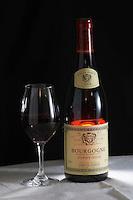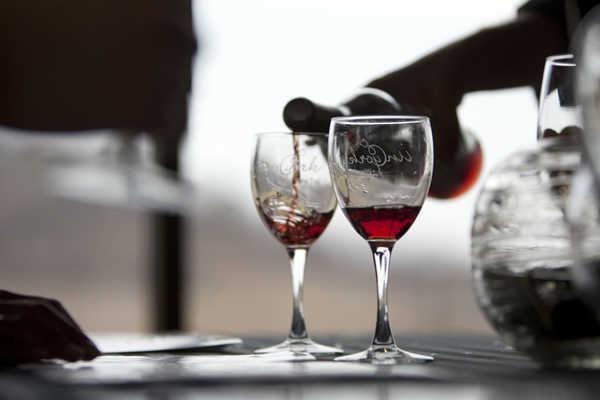The first image is the image on the left, the second image is the image on the right. Analyze the images presented: Is the assertion "In one of the images, there are two glasses of red wine side by side" valid? Answer yes or no. Yes. The first image is the image on the left, the second image is the image on the right. For the images displayed, is the sentence "There are at least six wine bottles in one of the images." factually correct? Answer yes or no. No. 